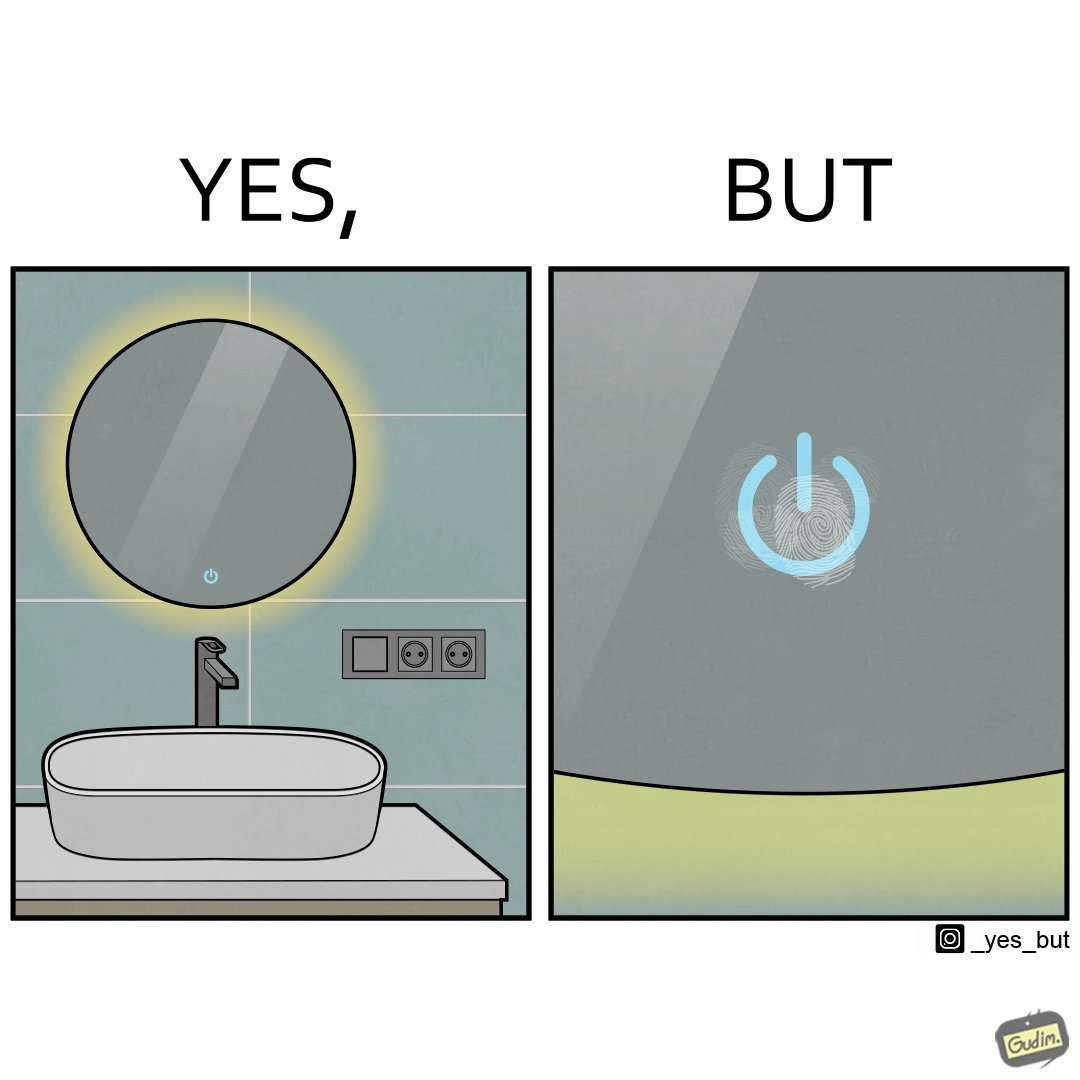What is shown in the left half versus the right half of this image? In the left part of the image: an apparently clean bathroom sink. In the right part of the image: The touch power button shows fingerprint smudges. 